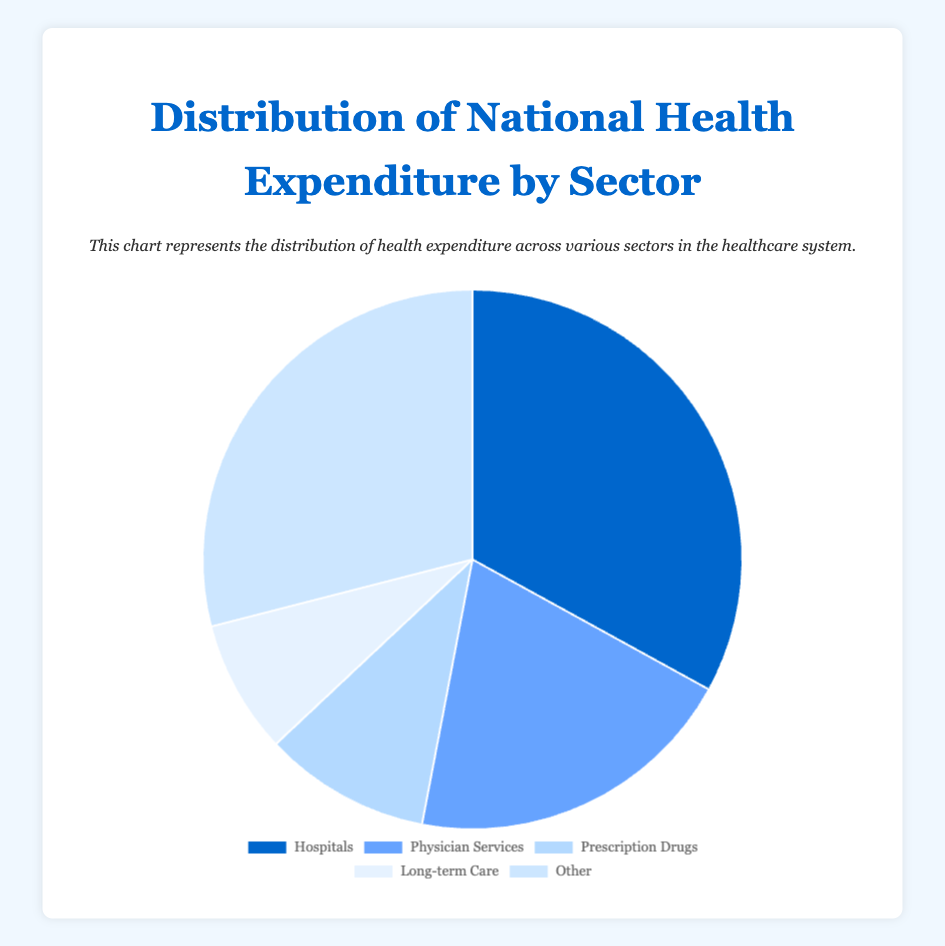How much larger is the Hospital expenditure compared to Prescription Drugs? The percentage for Hospitals is 33.0% while for Prescription Drugs it is 10.0%. The difference is found by subtracting the two percentages: 33.0% - 10.0% = 23.0%.
Answer: 23.0% What's the combined percentage of expenditure for Hospitals and Physician Services? To find the combined percentage, add the percentage of Hospitals (33.0%) and Physician Services (20.0%): 33.0% + 20.0% = 53.0%.
Answer: 53.0% Which sector has the lowest percentage of national health expenditure? By comparing the sectors, Long-term Care has the lowest percentage at 8.0%.
Answer: Long-term Care Is the expenditure on Hospitals greater than the combined expenditure on Prescription Drugs and Long-term Care? First, find the combined expenditure for Prescription Drugs and Long-term Care: 10.0% + 8.0% = 18.0%. Then compare it to the expenditure on Hospitals: 33.0% > 18.0%. Yes, Hospital expenditure is greater.
Answer: Yes What is the percentage difference between the highest and the lowest sector expenditures? The highest expenditure is for Hospitals at 33.0% and the lowest is Long-term Care at 8.0%. The difference is 33.0% - 8.0% = 25.0%.
Answer: 25.0% If "Other" represents expenditures not detailed separately, what sectors together exceed this "Other" expenditure? "Other" represents 29.0%. The combined percentage for Hospitals and Physician Services is 33.0% + 20.0% = 53.0%, which exceeds 29.0%.
Answer: Hospitals and Physician Services Which sector has nearly double the expenditure of Long-term Care? Long-term Care has 8.0%. The sector close to double this percentage is Physician Services with 20.0%, which is just a bit more than double.
Answer: Physician Services 